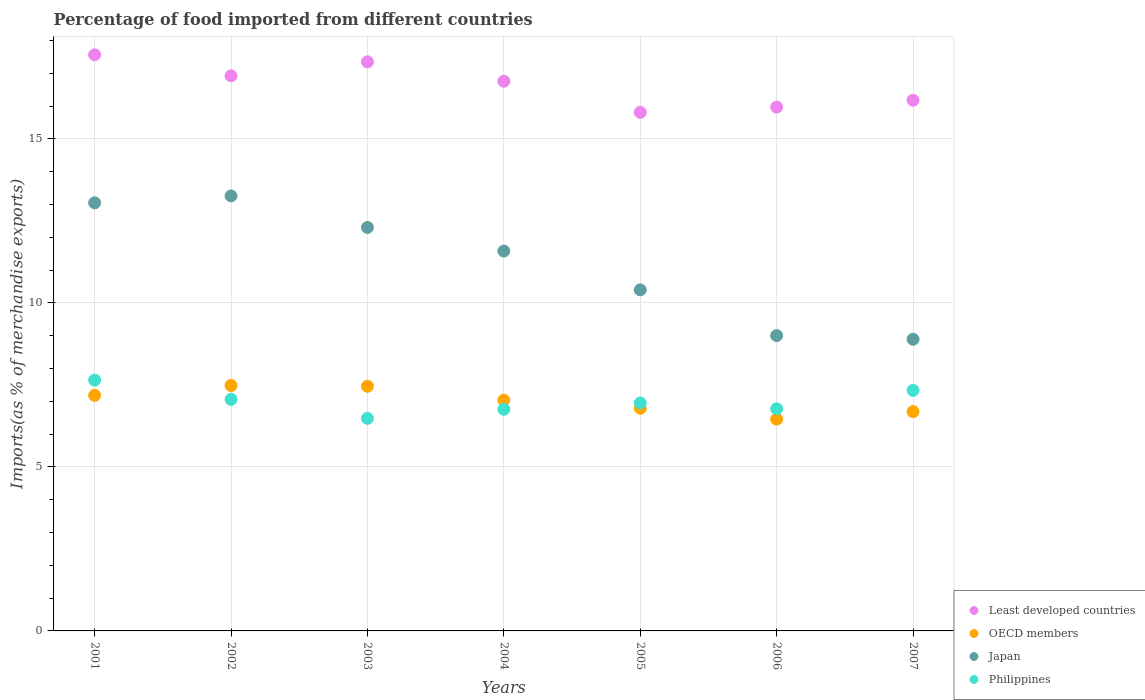What is the percentage of imports to different countries in Japan in 2004?
Your answer should be very brief. 11.58. Across all years, what is the maximum percentage of imports to different countries in Japan?
Provide a succinct answer. 13.26. Across all years, what is the minimum percentage of imports to different countries in Least developed countries?
Your answer should be compact. 15.81. In which year was the percentage of imports to different countries in Philippines minimum?
Offer a terse response. 2003. What is the total percentage of imports to different countries in OECD members in the graph?
Your answer should be compact. 49.08. What is the difference between the percentage of imports to different countries in Japan in 2006 and that in 2007?
Provide a short and direct response. 0.11. What is the difference between the percentage of imports to different countries in Least developed countries in 2006 and the percentage of imports to different countries in OECD members in 2005?
Offer a very short reply. 9.18. What is the average percentage of imports to different countries in Japan per year?
Make the answer very short. 11.21. In the year 2003, what is the difference between the percentage of imports to different countries in Philippines and percentage of imports to different countries in Least developed countries?
Ensure brevity in your answer.  -10.87. In how many years, is the percentage of imports to different countries in Philippines greater than 14 %?
Keep it short and to the point. 0. What is the ratio of the percentage of imports to different countries in Philippines in 2003 to that in 2007?
Make the answer very short. 0.88. Is the percentage of imports to different countries in OECD members in 2006 less than that in 2007?
Ensure brevity in your answer.  Yes. Is the difference between the percentage of imports to different countries in Philippines in 2004 and 2007 greater than the difference between the percentage of imports to different countries in Least developed countries in 2004 and 2007?
Make the answer very short. No. What is the difference between the highest and the second highest percentage of imports to different countries in OECD members?
Your response must be concise. 0.02. What is the difference between the highest and the lowest percentage of imports to different countries in OECD members?
Provide a short and direct response. 1.02. In how many years, is the percentage of imports to different countries in Philippines greater than the average percentage of imports to different countries in Philippines taken over all years?
Make the answer very short. 3. Is it the case that in every year, the sum of the percentage of imports to different countries in Philippines and percentage of imports to different countries in Least developed countries  is greater than the percentage of imports to different countries in OECD members?
Keep it short and to the point. Yes. Does the percentage of imports to different countries in Least developed countries monotonically increase over the years?
Your response must be concise. No. Is the percentage of imports to different countries in Least developed countries strictly greater than the percentage of imports to different countries in Japan over the years?
Ensure brevity in your answer.  Yes. Is the percentage of imports to different countries in Least developed countries strictly less than the percentage of imports to different countries in OECD members over the years?
Offer a terse response. No. How many dotlines are there?
Your answer should be very brief. 4. Where does the legend appear in the graph?
Your answer should be compact. Bottom right. How many legend labels are there?
Your answer should be very brief. 4. What is the title of the graph?
Give a very brief answer. Percentage of food imported from different countries. Does "Mongolia" appear as one of the legend labels in the graph?
Provide a succinct answer. No. What is the label or title of the X-axis?
Offer a terse response. Years. What is the label or title of the Y-axis?
Give a very brief answer. Imports(as % of merchandise exports). What is the Imports(as % of merchandise exports) of Least developed countries in 2001?
Ensure brevity in your answer.  17.56. What is the Imports(as % of merchandise exports) in OECD members in 2001?
Keep it short and to the point. 7.18. What is the Imports(as % of merchandise exports) of Japan in 2001?
Your answer should be compact. 13.05. What is the Imports(as % of merchandise exports) of Philippines in 2001?
Your response must be concise. 7.65. What is the Imports(as % of merchandise exports) in Least developed countries in 2002?
Make the answer very short. 16.92. What is the Imports(as % of merchandise exports) in OECD members in 2002?
Ensure brevity in your answer.  7.48. What is the Imports(as % of merchandise exports) in Japan in 2002?
Your answer should be compact. 13.26. What is the Imports(as % of merchandise exports) in Philippines in 2002?
Provide a succinct answer. 7.06. What is the Imports(as % of merchandise exports) of Least developed countries in 2003?
Ensure brevity in your answer.  17.35. What is the Imports(as % of merchandise exports) in OECD members in 2003?
Offer a terse response. 7.46. What is the Imports(as % of merchandise exports) of Japan in 2003?
Give a very brief answer. 12.3. What is the Imports(as % of merchandise exports) in Philippines in 2003?
Your answer should be compact. 6.48. What is the Imports(as % of merchandise exports) in Least developed countries in 2004?
Ensure brevity in your answer.  16.76. What is the Imports(as % of merchandise exports) of OECD members in 2004?
Offer a very short reply. 7.03. What is the Imports(as % of merchandise exports) of Japan in 2004?
Provide a short and direct response. 11.58. What is the Imports(as % of merchandise exports) of Philippines in 2004?
Ensure brevity in your answer.  6.76. What is the Imports(as % of merchandise exports) of Least developed countries in 2005?
Give a very brief answer. 15.81. What is the Imports(as % of merchandise exports) of OECD members in 2005?
Ensure brevity in your answer.  6.79. What is the Imports(as % of merchandise exports) in Japan in 2005?
Keep it short and to the point. 10.4. What is the Imports(as % of merchandise exports) of Philippines in 2005?
Your answer should be compact. 6.95. What is the Imports(as % of merchandise exports) in Least developed countries in 2006?
Provide a succinct answer. 15.97. What is the Imports(as % of merchandise exports) in OECD members in 2006?
Provide a succinct answer. 6.46. What is the Imports(as % of merchandise exports) of Japan in 2006?
Provide a succinct answer. 9. What is the Imports(as % of merchandise exports) in Philippines in 2006?
Your answer should be very brief. 6.77. What is the Imports(as % of merchandise exports) in Least developed countries in 2007?
Offer a terse response. 16.18. What is the Imports(as % of merchandise exports) in OECD members in 2007?
Keep it short and to the point. 6.69. What is the Imports(as % of merchandise exports) of Japan in 2007?
Ensure brevity in your answer.  8.89. What is the Imports(as % of merchandise exports) of Philippines in 2007?
Make the answer very short. 7.33. Across all years, what is the maximum Imports(as % of merchandise exports) in Least developed countries?
Your answer should be compact. 17.56. Across all years, what is the maximum Imports(as % of merchandise exports) in OECD members?
Offer a very short reply. 7.48. Across all years, what is the maximum Imports(as % of merchandise exports) of Japan?
Ensure brevity in your answer.  13.26. Across all years, what is the maximum Imports(as % of merchandise exports) in Philippines?
Make the answer very short. 7.65. Across all years, what is the minimum Imports(as % of merchandise exports) of Least developed countries?
Your response must be concise. 15.81. Across all years, what is the minimum Imports(as % of merchandise exports) of OECD members?
Offer a terse response. 6.46. Across all years, what is the minimum Imports(as % of merchandise exports) in Japan?
Keep it short and to the point. 8.89. Across all years, what is the minimum Imports(as % of merchandise exports) in Philippines?
Provide a short and direct response. 6.48. What is the total Imports(as % of merchandise exports) in Least developed countries in the graph?
Make the answer very short. 116.54. What is the total Imports(as % of merchandise exports) of OECD members in the graph?
Make the answer very short. 49.08. What is the total Imports(as % of merchandise exports) of Japan in the graph?
Your answer should be compact. 78.48. What is the total Imports(as % of merchandise exports) of Philippines in the graph?
Offer a very short reply. 48.99. What is the difference between the Imports(as % of merchandise exports) of Least developed countries in 2001 and that in 2002?
Give a very brief answer. 0.64. What is the difference between the Imports(as % of merchandise exports) in OECD members in 2001 and that in 2002?
Offer a terse response. -0.3. What is the difference between the Imports(as % of merchandise exports) in Japan in 2001 and that in 2002?
Offer a very short reply. -0.21. What is the difference between the Imports(as % of merchandise exports) in Philippines in 2001 and that in 2002?
Give a very brief answer. 0.59. What is the difference between the Imports(as % of merchandise exports) of Least developed countries in 2001 and that in 2003?
Keep it short and to the point. 0.21. What is the difference between the Imports(as % of merchandise exports) in OECD members in 2001 and that in 2003?
Offer a very short reply. -0.28. What is the difference between the Imports(as % of merchandise exports) in Japan in 2001 and that in 2003?
Offer a terse response. 0.75. What is the difference between the Imports(as % of merchandise exports) of Least developed countries in 2001 and that in 2004?
Ensure brevity in your answer.  0.81. What is the difference between the Imports(as % of merchandise exports) of OECD members in 2001 and that in 2004?
Make the answer very short. 0.15. What is the difference between the Imports(as % of merchandise exports) in Japan in 2001 and that in 2004?
Your answer should be very brief. 1.47. What is the difference between the Imports(as % of merchandise exports) of Philippines in 2001 and that in 2004?
Provide a succinct answer. 0.89. What is the difference between the Imports(as % of merchandise exports) of Least developed countries in 2001 and that in 2005?
Provide a succinct answer. 1.76. What is the difference between the Imports(as % of merchandise exports) of OECD members in 2001 and that in 2005?
Offer a very short reply. 0.39. What is the difference between the Imports(as % of merchandise exports) of Japan in 2001 and that in 2005?
Provide a short and direct response. 2.65. What is the difference between the Imports(as % of merchandise exports) of Philippines in 2001 and that in 2005?
Your answer should be compact. 0.7. What is the difference between the Imports(as % of merchandise exports) of Least developed countries in 2001 and that in 2006?
Your answer should be compact. 1.59. What is the difference between the Imports(as % of merchandise exports) of OECD members in 2001 and that in 2006?
Provide a succinct answer. 0.72. What is the difference between the Imports(as % of merchandise exports) of Japan in 2001 and that in 2006?
Offer a very short reply. 4.05. What is the difference between the Imports(as % of merchandise exports) of Philippines in 2001 and that in 2006?
Offer a terse response. 0.88. What is the difference between the Imports(as % of merchandise exports) in Least developed countries in 2001 and that in 2007?
Provide a short and direct response. 1.38. What is the difference between the Imports(as % of merchandise exports) in OECD members in 2001 and that in 2007?
Your answer should be compact. 0.5. What is the difference between the Imports(as % of merchandise exports) of Japan in 2001 and that in 2007?
Your answer should be very brief. 4.16. What is the difference between the Imports(as % of merchandise exports) of Philippines in 2001 and that in 2007?
Your answer should be very brief. 0.31. What is the difference between the Imports(as % of merchandise exports) of Least developed countries in 2002 and that in 2003?
Your answer should be very brief. -0.43. What is the difference between the Imports(as % of merchandise exports) of OECD members in 2002 and that in 2003?
Ensure brevity in your answer.  0.02. What is the difference between the Imports(as % of merchandise exports) in Japan in 2002 and that in 2003?
Keep it short and to the point. 0.96. What is the difference between the Imports(as % of merchandise exports) of Philippines in 2002 and that in 2003?
Offer a very short reply. 0.58. What is the difference between the Imports(as % of merchandise exports) of Least developed countries in 2002 and that in 2004?
Offer a very short reply. 0.17. What is the difference between the Imports(as % of merchandise exports) in OECD members in 2002 and that in 2004?
Offer a terse response. 0.45. What is the difference between the Imports(as % of merchandise exports) of Japan in 2002 and that in 2004?
Ensure brevity in your answer.  1.68. What is the difference between the Imports(as % of merchandise exports) in Philippines in 2002 and that in 2004?
Your response must be concise. 0.3. What is the difference between the Imports(as % of merchandise exports) of Least developed countries in 2002 and that in 2005?
Your answer should be very brief. 1.11. What is the difference between the Imports(as % of merchandise exports) of OECD members in 2002 and that in 2005?
Provide a succinct answer. 0.69. What is the difference between the Imports(as % of merchandise exports) in Japan in 2002 and that in 2005?
Make the answer very short. 2.86. What is the difference between the Imports(as % of merchandise exports) of Philippines in 2002 and that in 2005?
Keep it short and to the point. 0.11. What is the difference between the Imports(as % of merchandise exports) in Least developed countries in 2002 and that in 2006?
Your answer should be very brief. 0.95. What is the difference between the Imports(as % of merchandise exports) in OECD members in 2002 and that in 2006?
Provide a succinct answer. 1.02. What is the difference between the Imports(as % of merchandise exports) in Japan in 2002 and that in 2006?
Your response must be concise. 4.26. What is the difference between the Imports(as % of merchandise exports) in Philippines in 2002 and that in 2006?
Keep it short and to the point. 0.29. What is the difference between the Imports(as % of merchandise exports) of Least developed countries in 2002 and that in 2007?
Keep it short and to the point. 0.74. What is the difference between the Imports(as % of merchandise exports) in OECD members in 2002 and that in 2007?
Make the answer very short. 0.8. What is the difference between the Imports(as % of merchandise exports) of Japan in 2002 and that in 2007?
Your answer should be very brief. 4.37. What is the difference between the Imports(as % of merchandise exports) in Philippines in 2002 and that in 2007?
Provide a succinct answer. -0.27. What is the difference between the Imports(as % of merchandise exports) of Least developed countries in 2003 and that in 2004?
Your response must be concise. 0.59. What is the difference between the Imports(as % of merchandise exports) in OECD members in 2003 and that in 2004?
Your answer should be very brief. 0.42. What is the difference between the Imports(as % of merchandise exports) of Japan in 2003 and that in 2004?
Provide a succinct answer. 0.72. What is the difference between the Imports(as % of merchandise exports) in Philippines in 2003 and that in 2004?
Make the answer very short. -0.28. What is the difference between the Imports(as % of merchandise exports) of Least developed countries in 2003 and that in 2005?
Your answer should be compact. 1.54. What is the difference between the Imports(as % of merchandise exports) in OECD members in 2003 and that in 2005?
Keep it short and to the point. 0.67. What is the difference between the Imports(as % of merchandise exports) in Japan in 2003 and that in 2005?
Keep it short and to the point. 1.9. What is the difference between the Imports(as % of merchandise exports) of Philippines in 2003 and that in 2005?
Offer a terse response. -0.47. What is the difference between the Imports(as % of merchandise exports) of Least developed countries in 2003 and that in 2006?
Your answer should be compact. 1.38. What is the difference between the Imports(as % of merchandise exports) in Japan in 2003 and that in 2006?
Offer a terse response. 3.3. What is the difference between the Imports(as % of merchandise exports) of Philippines in 2003 and that in 2006?
Offer a terse response. -0.29. What is the difference between the Imports(as % of merchandise exports) in Least developed countries in 2003 and that in 2007?
Provide a short and direct response. 1.17. What is the difference between the Imports(as % of merchandise exports) of OECD members in 2003 and that in 2007?
Your answer should be compact. 0.77. What is the difference between the Imports(as % of merchandise exports) in Japan in 2003 and that in 2007?
Make the answer very short. 3.41. What is the difference between the Imports(as % of merchandise exports) of Philippines in 2003 and that in 2007?
Keep it short and to the point. -0.85. What is the difference between the Imports(as % of merchandise exports) of Least developed countries in 2004 and that in 2005?
Give a very brief answer. 0.95. What is the difference between the Imports(as % of merchandise exports) of OECD members in 2004 and that in 2005?
Your response must be concise. 0.25. What is the difference between the Imports(as % of merchandise exports) of Japan in 2004 and that in 2005?
Offer a very short reply. 1.18. What is the difference between the Imports(as % of merchandise exports) of Philippines in 2004 and that in 2005?
Offer a very short reply. -0.19. What is the difference between the Imports(as % of merchandise exports) in Least developed countries in 2004 and that in 2006?
Your answer should be compact. 0.79. What is the difference between the Imports(as % of merchandise exports) of OECD members in 2004 and that in 2006?
Ensure brevity in your answer.  0.58. What is the difference between the Imports(as % of merchandise exports) of Japan in 2004 and that in 2006?
Your response must be concise. 2.58. What is the difference between the Imports(as % of merchandise exports) in Philippines in 2004 and that in 2006?
Your answer should be compact. -0.01. What is the difference between the Imports(as % of merchandise exports) in Least developed countries in 2004 and that in 2007?
Offer a very short reply. 0.58. What is the difference between the Imports(as % of merchandise exports) of OECD members in 2004 and that in 2007?
Keep it short and to the point. 0.35. What is the difference between the Imports(as % of merchandise exports) in Japan in 2004 and that in 2007?
Your answer should be very brief. 2.69. What is the difference between the Imports(as % of merchandise exports) in Philippines in 2004 and that in 2007?
Offer a very short reply. -0.58. What is the difference between the Imports(as % of merchandise exports) in Least developed countries in 2005 and that in 2006?
Your answer should be compact. -0.16. What is the difference between the Imports(as % of merchandise exports) of OECD members in 2005 and that in 2006?
Your response must be concise. 0.33. What is the difference between the Imports(as % of merchandise exports) of Japan in 2005 and that in 2006?
Ensure brevity in your answer.  1.39. What is the difference between the Imports(as % of merchandise exports) of Philippines in 2005 and that in 2006?
Ensure brevity in your answer.  0.18. What is the difference between the Imports(as % of merchandise exports) of Least developed countries in 2005 and that in 2007?
Keep it short and to the point. -0.37. What is the difference between the Imports(as % of merchandise exports) in OECD members in 2005 and that in 2007?
Your response must be concise. 0.1. What is the difference between the Imports(as % of merchandise exports) of Japan in 2005 and that in 2007?
Ensure brevity in your answer.  1.51. What is the difference between the Imports(as % of merchandise exports) in Philippines in 2005 and that in 2007?
Make the answer very short. -0.39. What is the difference between the Imports(as % of merchandise exports) in Least developed countries in 2006 and that in 2007?
Make the answer very short. -0.21. What is the difference between the Imports(as % of merchandise exports) of OECD members in 2006 and that in 2007?
Make the answer very short. -0.23. What is the difference between the Imports(as % of merchandise exports) in Japan in 2006 and that in 2007?
Offer a terse response. 0.11. What is the difference between the Imports(as % of merchandise exports) of Philippines in 2006 and that in 2007?
Offer a terse response. -0.56. What is the difference between the Imports(as % of merchandise exports) in Least developed countries in 2001 and the Imports(as % of merchandise exports) in OECD members in 2002?
Offer a very short reply. 10.08. What is the difference between the Imports(as % of merchandise exports) of Least developed countries in 2001 and the Imports(as % of merchandise exports) of Japan in 2002?
Ensure brevity in your answer.  4.3. What is the difference between the Imports(as % of merchandise exports) of Least developed countries in 2001 and the Imports(as % of merchandise exports) of Philippines in 2002?
Provide a succinct answer. 10.5. What is the difference between the Imports(as % of merchandise exports) in OECD members in 2001 and the Imports(as % of merchandise exports) in Japan in 2002?
Your answer should be compact. -6.08. What is the difference between the Imports(as % of merchandise exports) in OECD members in 2001 and the Imports(as % of merchandise exports) in Philippines in 2002?
Give a very brief answer. 0.12. What is the difference between the Imports(as % of merchandise exports) of Japan in 2001 and the Imports(as % of merchandise exports) of Philippines in 2002?
Offer a terse response. 5.99. What is the difference between the Imports(as % of merchandise exports) of Least developed countries in 2001 and the Imports(as % of merchandise exports) of OECD members in 2003?
Your response must be concise. 10.11. What is the difference between the Imports(as % of merchandise exports) of Least developed countries in 2001 and the Imports(as % of merchandise exports) of Japan in 2003?
Your response must be concise. 5.26. What is the difference between the Imports(as % of merchandise exports) in Least developed countries in 2001 and the Imports(as % of merchandise exports) in Philippines in 2003?
Ensure brevity in your answer.  11.08. What is the difference between the Imports(as % of merchandise exports) of OECD members in 2001 and the Imports(as % of merchandise exports) of Japan in 2003?
Your answer should be compact. -5.12. What is the difference between the Imports(as % of merchandise exports) of OECD members in 2001 and the Imports(as % of merchandise exports) of Philippines in 2003?
Ensure brevity in your answer.  0.7. What is the difference between the Imports(as % of merchandise exports) of Japan in 2001 and the Imports(as % of merchandise exports) of Philippines in 2003?
Keep it short and to the point. 6.57. What is the difference between the Imports(as % of merchandise exports) in Least developed countries in 2001 and the Imports(as % of merchandise exports) in OECD members in 2004?
Your answer should be very brief. 10.53. What is the difference between the Imports(as % of merchandise exports) in Least developed countries in 2001 and the Imports(as % of merchandise exports) in Japan in 2004?
Your response must be concise. 5.98. What is the difference between the Imports(as % of merchandise exports) in Least developed countries in 2001 and the Imports(as % of merchandise exports) in Philippines in 2004?
Provide a succinct answer. 10.81. What is the difference between the Imports(as % of merchandise exports) in OECD members in 2001 and the Imports(as % of merchandise exports) in Japan in 2004?
Ensure brevity in your answer.  -4.4. What is the difference between the Imports(as % of merchandise exports) in OECD members in 2001 and the Imports(as % of merchandise exports) in Philippines in 2004?
Your response must be concise. 0.43. What is the difference between the Imports(as % of merchandise exports) of Japan in 2001 and the Imports(as % of merchandise exports) of Philippines in 2004?
Give a very brief answer. 6.29. What is the difference between the Imports(as % of merchandise exports) of Least developed countries in 2001 and the Imports(as % of merchandise exports) of OECD members in 2005?
Your response must be concise. 10.78. What is the difference between the Imports(as % of merchandise exports) in Least developed countries in 2001 and the Imports(as % of merchandise exports) in Japan in 2005?
Ensure brevity in your answer.  7.17. What is the difference between the Imports(as % of merchandise exports) of Least developed countries in 2001 and the Imports(as % of merchandise exports) of Philippines in 2005?
Offer a terse response. 10.61. What is the difference between the Imports(as % of merchandise exports) of OECD members in 2001 and the Imports(as % of merchandise exports) of Japan in 2005?
Provide a succinct answer. -3.22. What is the difference between the Imports(as % of merchandise exports) in OECD members in 2001 and the Imports(as % of merchandise exports) in Philippines in 2005?
Your response must be concise. 0.23. What is the difference between the Imports(as % of merchandise exports) of Japan in 2001 and the Imports(as % of merchandise exports) of Philippines in 2005?
Your answer should be compact. 6.1. What is the difference between the Imports(as % of merchandise exports) of Least developed countries in 2001 and the Imports(as % of merchandise exports) of OECD members in 2006?
Offer a very short reply. 11.11. What is the difference between the Imports(as % of merchandise exports) of Least developed countries in 2001 and the Imports(as % of merchandise exports) of Japan in 2006?
Keep it short and to the point. 8.56. What is the difference between the Imports(as % of merchandise exports) in Least developed countries in 2001 and the Imports(as % of merchandise exports) in Philippines in 2006?
Make the answer very short. 10.79. What is the difference between the Imports(as % of merchandise exports) in OECD members in 2001 and the Imports(as % of merchandise exports) in Japan in 2006?
Make the answer very short. -1.82. What is the difference between the Imports(as % of merchandise exports) of OECD members in 2001 and the Imports(as % of merchandise exports) of Philippines in 2006?
Your answer should be compact. 0.41. What is the difference between the Imports(as % of merchandise exports) of Japan in 2001 and the Imports(as % of merchandise exports) of Philippines in 2006?
Your answer should be compact. 6.28. What is the difference between the Imports(as % of merchandise exports) in Least developed countries in 2001 and the Imports(as % of merchandise exports) in OECD members in 2007?
Give a very brief answer. 10.88. What is the difference between the Imports(as % of merchandise exports) in Least developed countries in 2001 and the Imports(as % of merchandise exports) in Japan in 2007?
Make the answer very short. 8.67. What is the difference between the Imports(as % of merchandise exports) in Least developed countries in 2001 and the Imports(as % of merchandise exports) in Philippines in 2007?
Make the answer very short. 10.23. What is the difference between the Imports(as % of merchandise exports) in OECD members in 2001 and the Imports(as % of merchandise exports) in Japan in 2007?
Give a very brief answer. -1.71. What is the difference between the Imports(as % of merchandise exports) in OECD members in 2001 and the Imports(as % of merchandise exports) in Philippines in 2007?
Provide a succinct answer. -0.15. What is the difference between the Imports(as % of merchandise exports) of Japan in 2001 and the Imports(as % of merchandise exports) of Philippines in 2007?
Provide a succinct answer. 5.72. What is the difference between the Imports(as % of merchandise exports) of Least developed countries in 2002 and the Imports(as % of merchandise exports) of OECD members in 2003?
Keep it short and to the point. 9.46. What is the difference between the Imports(as % of merchandise exports) of Least developed countries in 2002 and the Imports(as % of merchandise exports) of Japan in 2003?
Make the answer very short. 4.62. What is the difference between the Imports(as % of merchandise exports) in Least developed countries in 2002 and the Imports(as % of merchandise exports) in Philippines in 2003?
Make the answer very short. 10.44. What is the difference between the Imports(as % of merchandise exports) of OECD members in 2002 and the Imports(as % of merchandise exports) of Japan in 2003?
Ensure brevity in your answer.  -4.82. What is the difference between the Imports(as % of merchandise exports) of OECD members in 2002 and the Imports(as % of merchandise exports) of Philippines in 2003?
Offer a terse response. 1. What is the difference between the Imports(as % of merchandise exports) of Japan in 2002 and the Imports(as % of merchandise exports) of Philippines in 2003?
Give a very brief answer. 6.78. What is the difference between the Imports(as % of merchandise exports) of Least developed countries in 2002 and the Imports(as % of merchandise exports) of OECD members in 2004?
Provide a short and direct response. 9.89. What is the difference between the Imports(as % of merchandise exports) in Least developed countries in 2002 and the Imports(as % of merchandise exports) in Japan in 2004?
Offer a very short reply. 5.34. What is the difference between the Imports(as % of merchandise exports) in Least developed countries in 2002 and the Imports(as % of merchandise exports) in Philippines in 2004?
Your response must be concise. 10.17. What is the difference between the Imports(as % of merchandise exports) in OECD members in 2002 and the Imports(as % of merchandise exports) in Japan in 2004?
Keep it short and to the point. -4.1. What is the difference between the Imports(as % of merchandise exports) of OECD members in 2002 and the Imports(as % of merchandise exports) of Philippines in 2004?
Your answer should be compact. 0.72. What is the difference between the Imports(as % of merchandise exports) of Japan in 2002 and the Imports(as % of merchandise exports) of Philippines in 2004?
Your answer should be compact. 6.5. What is the difference between the Imports(as % of merchandise exports) of Least developed countries in 2002 and the Imports(as % of merchandise exports) of OECD members in 2005?
Make the answer very short. 10.13. What is the difference between the Imports(as % of merchandise exports) in Least developed countries in 2002 and the Imports(as % of merchandise exports) in Japan in 2005?
Keep it short and to the point. 6.52. What is the difference between the Imports(as % of merchandise exports) in Least developed countries in 2002 and the Imports(as % of merchandise exports) in Philippines in 2005?
Make the answer very short. 9.97. What is the difference between the Imports(as % of merchandise exports) of OECD members in 2002 and the Imports(as % of merchandise exports) of Japan in 2005?
Your answer should be very brief. -2.92. What is the difference between the Imports(as % of merchandise exports) in OECD members in 2002 and the Imports(as % of merchandise exports) in Philippines in 2005?
Provide a succinct answer. 0.53. What is the difference between the Imports(as % of merchandise exports) of Japan in 2002 and the Imports(as % of merchandise exports) of Philippines in 2005?
Keep it short and to the point. 6.31. What is the difference between the Imports(as % of merchandise exports) of Least developed countries in 2002 and the Imports(as % of merchandise exports) of OECD members in 2006?
Ensure brevity in your answer.  10.47. What is the difference between the Imports(as % of merchandise exports) of Least developed countries in 2002 and the Imports(as % of merchandise exports) of Japan in 2006?
Your response must be concise. 7.92. What is the difference between the Imports(as % of merchandise exports) of Least developed countries in 2002 and the Imports(as % of merchandise exports) of Philippines in 2006?
Provide a short and direct response. 10.15. What is the difference between the Imports(as % of merchandise exports) in OECD members in 2002 and the Imports(as % of merchandise exports) in Japan in 2006?
Your answer should be very brief. -1.52. What is the difference between the Imports(as % of merchandise exports) in OECD members in 2002 and the Imports(as % of merchandise exports) in Philippines in 2006?
Your answer should be very brief. 0.71. What is the difference between the Imports(as % of merchandise exports) in Japan in 2002 and the Imports(as % of merchandise exports) in Philippines in 2006?
Your answer should be compact. 6.49. What is the difference between the Imports(as % of merchandise exports) of Least developed countries in 2002 and the Imports(as % of merchandise exports) of OECD members in 2007?
Offer a very short reply. 10.24. What is the difference between the Imports(as % of merchandise exports) of Least developed countries in 2002 and the Imports(as % of merchandise exports) of Japan in 2007?
Your answer should be very brief. 8.03. What is the difference between the Imports(as % of merchandise exports) in Least developed countries in 2002 and the Imports(as % of merchandise exports) in Philippines in 2007?
Your response must be concise. 9.59. What is the difference between the Imports(as % of merchandise exports) of OECD members in 2002 and the Imports(as % of merchandise exports) of Japan in 2007?
Your answer should be very brief. -1.41. What is the difference between the Imports(as % of merchandise exports) of OECD members in 2002 and the Imports(as % of merchandise exports) of Philippines in 2007?
Keep it short and to the point. 0.15. What is the difference between the Imports(as % of merchandise exports) in Japan in 2002 and the Imports(as % of merchandise exports) in Philippines in 2007?
Ensure brevity in your answer.  5.93. What is the difference between the Imports(as % of merchandise exports) in Least developed countries in 2003 and the Imports(as % of merchandise exports) in OECD members in 2004?
Provide a short and direct response. 10.31. What is the difference between the Imports(as % of merchandise exports) in Least developed countries in 2003 and the Imports(as % of merchandise exports) in Japan in 2004?
Offer a very short reply. 5.77. What is the difference between the Imports(as % of merchandise exports) in Least developed countries in 2003 and the Imports(as % of merchandise exports) in Philippines in 2004?
Provide a short and direct response. 10.59. What is the difference between the Imports(as % of merchandise exports) in OECD members in 2003 and the Imports(as % of merchandise exports) in Japan in 2004?
Your answer should be very brief. -4.12. What is the difference between the Imports(as % of merchandise exports) of OECD members in 2003 and the Imports(as % of merchandise exports) of Philippines in 2004?
Give a very brief answer. 0.7. What is the difference between the Imports(as % of merchandise exports) of Japan in 2003 and the Imports(as % of merchandise exports) of Philippines in 2004?
Give a very brief answer. 5.54. What is the difference between the Imports(as % of merchandise exports) of Least developed countries in 2003 and the Imports(as % of merchandise exports) of OECD members in 2005?
Your response must be concise. 10.56. What is the difference between the Imports(as % of merchandise exports) of Least developed countries in 2003 and the Imports(as % of merchandise exports) of Japan in 2005?
Give a very brief answer. 6.95. What is the difference between the Imports(as % of merchandise exports) of Least developed countries in 2003 and the Imports(as % of merchandise exports) of Philippines in 2005?
Keep it short and to the point. 10.4. What is the difference between the Imports(as % of merchandise exports) of OECD members in 2003 and the Imports(as % of merchandise exports) of Japan in 2005?
Give a very brief answer. -2.94. What is the difference between the Imports(as % of merchandise exports) of OECD members in 2003 and the Imports(as % of merchandise exports) of Philippines in 2005?
Provide a succinct answer. 0.51. What is the difference between the Imports(as % of merchandise exports) in Japan in 2003 and the Imports(as % of merchandise exports) in Philippines in 2005?
Ensure brevity in your answer.  5.35. What is the difference between the Imports(as % of merchandise exports) of Least developed countries in 2003 and the Imports(as % of merchandise exports) of OECD members in 2006?
Provide a succinct answer. 10.89. What is the difference between the Imports(as % of merchandise exports) of Least developed countries in 2003 and the Imports(as % of merchandise exports) of Japan in 2006?
Give a very brief answer. 8.35. What is the difference between the Imports(as % of merchandise exports) in Least developed countries in 2003 and the Imports(as % of merchandise exports) in Philippines in 2006?
Your answer should be compact. 10.58. What is the difference between the Imports(as % of merchandise exports) in OECD members in 2003 and the Imports(as % of merchandise exports) in Japan in 2006?
Make the answer very short. -1.55. What is the difference between the Imports(as % of merchandise exports) in OECD members in 2003 and the Imports(as % of merchandise exports) in Philippines in 2006?
Provide a succinct answer. 0.69. What is the difference between the Imports(as % of merchandise exports) in Japan in 2003 and the Imports(as % of merchandise exports) in Philippines in 2006?
Give a very brief answer. 5.53. What is the difference between the Imports(as % of merchandise exports) of Least developed countries in 2003 and the Imports(as % of merchandise exports) of OECD members in 2007?
Offer a terse response. 10.66. What is the difference between the Imports(as % of merchandise exports) in Least developed countries in 2003 and the Imports(as % of merchandise exports) in Japan in 2007?
Your answer should be compact. 8.46. What is the difference between the Imports(as % of merchandise exports) of Least developed countries in 2003 and the Imports(as % of merchandise exports) of Philippines in 2007?
Offer a terse response. 10.02. What is the difference between the Imports(as % of merchandise exports) of OECD members in 2003 and the Imports(as % of merchandise exports) of Japan in 2007?
Keep it short and to the point. -1.43. What is the difference between the Imports(as % of merchandise exports) in OECD members in 2003 and the Imports(as % of merchandise exports) in Philippines in 2007?
Your answer should be very brief. 0.12. What is the difference between the Imports(as % of merchandise exports) of Japan in 2003 and the Imports(as % of merchandise exports) of Philippines in 2007?
Keep it short and to the point. 4.97. What is the difference between the Imports(as % of merchandise exports) in Least developed countries in 2004 and the Imports(as % of merchandise exports) in OECD members in 2005?
Provide a succinct answer. 9.97. What is the difference between the Imports(as % of merchandise exports) in Least developed countries in 2004 and the Imports(as % of merchandise exports) in Japan in 2005?
Make the answer very short. 6.36. What is the difference between the Imports(as % of merchandise exports) of Least developed countries in 2004 and the Imports(as % of merchandise exports) of Philippines in 2005?
Offer a very short reply. 9.81. What is the difference between the Imports(as % of merchandise exports) of OECD members in 2004 and the Imports(as % of merchandise exports) of Japan in 2005?
Your answer should be compact. -3.36. What is the difference between the Imports(as % of merchandise exports) in OECD members in 2004 and the Imports(as % of merchandise exports) in Philippines in 2005?
Give a very brief answer. 0.09. What is the difference between the Imports(as % of merchandise exports) of Japan in 2004 and the Imports(as % of merchandise exports) of Philippines in 2005?
Provide a succinct answer. 4.63. What is the difference between the Imports(as % of merchandise exports) in Least developed countries in 2004 and the Imports(as % of merchandise exports) in OECD members in 2006?
Your answer should be compact. 10.3. What is the difference between the Imports(as % of merchandise exports) in Least developed countries in 2004 and the Imports(as % of merchandise exports) in Japan in 2006?
Give a very brief answer. 7.75. What is the difference between the Imports(as % of merchandise exports) of Least developed countries in 2004 and the Imports(as % of merchandise exports) of Philippines in 2006?
Provide a succinct answer. 9.99. What is the difference between the Imports(as % of merchandise exports) of OECD members in 2004 and the Imports(as % of merchandise exports) of Japan in 2006?
Make the answer very short. -1.97. What is the difference between the Imports(as % of merchandise exports) in OECD members in 2004 and the Imports(as % of merchandise exports) in Philippines in 2006?
Your response must be concise. 0.26. What is the difference between the Imports(as % of merchandise exports) of Japan in 2004 and the Imports(as % of merchandise exports) of Philippines in 2006?
Keep it short and to the point. 4.81. What is the difference between the Imports(as % of merchandise exports) of Least developed countries in 2004 and the Imports(as % of merchandise exports) of OECD members in 2007?
Keep it short and to the point. 10.07. What is the difference between the Imports(as % of merchandise exports) in Least developed countries in 2004 and the Imports(as % of merchandise exports) in Japan in 2007?
Give a very brief answer. 7.86. What is the difference between the Imports(as % of merchandise exports) in Least developed countries in 2004 and the Imports(as % of merchandise exports) in Philippines in 2007?
Offer a very short reply. 9.42. What is the difference between the Imports(as % of merchandise exports) in OECD members in 2004 and the Imports(as % of merchandise exports) in Japan in 2007?
Ensure brevity in your answer.  -1.86. What is the difference between the Imports(as % of merchandise exports) in OECD members in 2004 and the Imports(as % of merchandise exports) in Philippines in 2007?
Provide a succinct answer. -0.3. What is the difference between the Imports(as % of merchandise exports) of Japan in 2004 and the Imports(as % of merchandise exports) of Philippines in 2007?
Your answer should be compact. 4.25. What is the difference between the Imports(as % of merchandise exports) of Least developed countries in 2005 and the Imports(as % of merchandise exports) of OECD members in 2006?
Offer a terse response. 9.35. What is the difference between the Imports(as % of merchandise exports) in Least developed countries in 2005 and the Imports(as % of merchandise exports) in Japan in 2006?
Your response must be concise. 6.8. What is the difference between the Imports(as % of merchandise exports) in Least developed countries in 2005 and the Imports(as % of merchandise exports) in Philippines in 2006?
Offer a terse response. 9.04. What is the difference between the Imports(as % of merchandise exports) in OECD members in 2005 and the Imports(as % of merchandise exports) in Japan in 2006?
Offer a very short reply. -2.22. What is the difference between the Imports(as % of merchandise exports) in OECD members in 2005 and the Imports(as % of merchandise exports) in Philippines in 2006?
Offer a terse response. 0.02. What is the difference between the Imports(as % of merchandise exports) in Japan in 2005 and the Imports(as % of merchandise exports) in Philippines in 2006?
Ensure brevity in your answer.  3.63. What is the difference between the Imports(as % of merchandise exports) in Least developed countries in 2005 and the Imports(as % of merchandise exports) in OECD members in 2007?
Give a very brief answer. 9.12. What is the difference between the Imports(as % of merchandise exports) in Least developed countries in 2005 and the Imports(as % of merchandise exports) in Japan in 2007?
Offer a terse response. 6.92. What is the difference between the Imports(as % of merchandise exports) of Least developed countries in 2005 and the Imports(as % of merchandise exports) of Philippines in 2007?
Offer a very short reply. 8.47. What is the difference between the Imports(as % of merchandise exports) of OECD members in 2005 and the Imports(as % of merchandise exports) of Japan in 2007?
Keep it short and to the point. -2.1. What is the difference between the Imports(as % of merchandise exports) of OECD members in 2005 and the Imports(as % of merchandise exports) of Philippines in 2007?
Your response must be concise. -0.55. What is the difference between the Imports(as % of merchandise exports) in Japan in 2005 and the Imports(as % of merchandise exports) in Philippines in 2007?
Make the answer very short. 3.06. What is the difference between the Imports(as % of merchandise exports) in Least developed countries in 2006 and the Imports(as % of merchandise exports) in OECD members in 2007?
Your response must be concise. 9.28. What is the difference between the Imports(as % of merchandise exports) of Least developed countries in 2006 and the Imports(as % of merchandise exports) of Japan in 2007?
Your answer should be very brief. 7.08. What is the difference between the Imports(as % of merchandise exports) of Least developed countries in 2006 and the Imports(as % of merchandise exports) of Philippines in 2007?
Your response must be concise. 8.64. What is the difference between the Imports(as % of merchandise exports) of OECD members in 2006 and the Imports(as % of merchandise exports) of Japan in 2007?
Make the answer very short. -2.43. What is the difference between the Imports(as % of merchandise exports) of OECD members in 2006 and the Imports(as % of merchandise exports) of Philippines in 2007?
Provide a short and direct response. -0.88. What is the difference between the Imports(as % of merchandise exports) in Japan in 2006 and the Imports(as % of merchandise exports) in Philippines in 2007?
Your answer should be compact. 1.67. What is the average Imports(as % of merchandise exports) of Least developed countries per year?
Provide a short and direct response. 16.65. What is the average Imports(as % of merchandise exports) of OECD members per year?
Provide a succinct answer. 7.01. What is the average Imports(as % of merchandise exports) of Japan per year?
Your response must be concise. 11.21. What is the average Imports(as % of merchandise exports) of Philippines per year?
Ensure brevity in your answer.  7. In the year 2001, what is the difference between the Imports(as % of merchandise exports) of Least developed countries and Imports(as % of merchandise exports) of OECD members?
Make the answer very short. 10.38. In the year 2001, what is the difference between the Imports(as % of merchandise exports) in Least developed countries and Imports(as % of merchandise exports) in Japan?
Ensure brevity in your answer.  4.51. In the year 2001, what is the difference between the Imports(as % of merchandise exports) in Least developed countries and Imports(as % of merchandise exports) in Philippines?
Provide a succinct answer. 9.92. In the year 2001, what is the difference between the Imports(as % of merchandise exports) in OECD members and Imports(as % of merchandise exports) in Japan?
Your answer should be very brief. -5.87. In the year 2001, what is the difference between the Imports(as % of merchandise exports) of OECD members and Imports(as % of merchandise exports) of Philippines?
Give a very brief answer. -0.46. In the year 2001, what is the difference between the Imports(as % of merchandise exports) in Japan and Imports(as % of merchandise exports) in Philippines?
Keep it short and to the point. 5.4. In the year 2002, what is the difference between the Imports(as % of merchandise exports) of Least developed countries and Imports(as % of merchandise exports) of OECD members?
Offer a terse response. 9.44. In the year 2002, what is the difference between the Imports(as % of merchandise exports) in Least developed countries and Imports(as % of merchandise exports) in Japan?
Your response must be concise. 3.66. In the year 2002, what is the difference between the Imports(as % of merchandise exports) in Least developed countries and Imports(as % of merchandise exports) in Philippines?
Provide a succinct answer. 9.86. In the year 2002, what is the difference between the Imports(as % of merchandise exports) in OECD members and Imports(as % of merchandise exports) in Japan?
Provide a short and direct response. -5.78. In the year 2002, what is the difference between the Imports(as % of merchandise exports) of OECD members and Imports(as % of merchandise exports) of Philippines?
Your answer should be very brief. 0.42. In the year 2002, what is the difference between the Imports(as % of merchandise exports) in Japan and Imports(as % of merchandise exports) in Philippines?
Provide a succinct answer. 6.2. In the year 2003, what is the difference between the Imports(as % of merchandise exports) of Least developed countries and Imports(as % of merchandise exports) of OECD members?
Provide a short and direct response. 9.89. In the year 2003, what is the difference between the Imports(as % of merchandise exports) of Least developed countries and Imports(as % of merchandise exports) of Japan?
Give a very brief answer. 5.05. In the year 2003, what is the difference between the Imports(as % of merchandise exports) in Least developed countries and Imports(as % of merchandise exports) in Philippines?
Give a very brief answer. 10.87. In the year 2003, what is the difference between the Imports(as % of merchandise exports) of OECD members and Imports(as % of merchandise exports) of Japan?
Offer a terse response. -4.84. In the year 2003, what is the difference between the Imports(as % of merchandise exports) in OECD members and Imports(as % of merchandise exports) in Philippines?
Provide a succinct answer. 0.98. In the year 2003, what is the difference between the Imports(as % of merchandise exports) of Japan and Imports(as % of merchandise exports) of Philippines?
Make the answer very short. 5.82. In the year 2004, what is the difference between the Imports(as % of merchandise exports) in Least developed countries and Imports(as % of merchandise exports) in OECD members?
Give a very brief answer. 9.72. In the year 2004, what is the difference between the Imports(as % of merchandise exports) of Least developed countries and Imports(as % of merchandise exports) of Japan?
Offer a very short reply. 5.18. In the year 2004, what is the difference between the Imports(as % of merchandise exports) of Least developed countries and Imports(as % of merchandise exports) of Philippines?
Your response must be concise. 10. In the year 2004, what is the difference between the Imports(as % of merchandise exports) in OECD members and Imports(as % of merchandise exports) in Japan?
Ensure brevity in your answer.  -4.55. In the year 2004, what is the difference between the Imports(as % of merchandise exports) in OECD members and Imports(as % of merchandise exports) in Philippines?
Offer a terse response. 0.28. In the year 2004, what is the difference between the Imports(as % of merchandise exports) of Japan and Imports(as % of merchandise exports) of Philippines?
Your answer should be very brief. 4.82. In the year 2005, what is the difference between the Imports(as % of merchandise exports) of Least developed countries and Imports(as % of merchandise exports) of OECD members?
Provide a short and direct response. 9.02. In the year 2005, what is the difference between the Imports(as % of merchandise exports) of Least developed countries and Imports(as % of merchandise exports) of Japan?
Offer a terse response. 5.41. In the year 2005, what is the difference between the Imports(as % of merchandise exports) in Least developed countries and Imports(as % of merchandise exports) in Philippines?
Provide a short and direct response. 8.86. In the year 2005, what is the difference between the Imports(as % of merchandise exports) of OECD members and Imports(as % of merchandise exports) of Japan?
Offer a terse response. -3.61. In the year 2005, what is the difference between the Imports(as % of merchandise exports) of OECD members and Imports(as % of merchandise exports) of Philippines?
Your answer should be very brief. -0.16. In the year 2005, what is the difference between the Imports(as % of merchandise exports) in Japan and Imports(as % of merchandise exports) in Philippines?
Provide a short and direct response. 3.45. In the year 2006, what is the difference between the Imports(as % of merchandise exports) of Least developed countries and Imports(as % of merchandise exports) of OECD members?
Offer a very short reply. 9.51. In the year 2006, what is the difference between the Imports(as % of merchandise exports) in Least developed countries and Imports(as % of merchandise exports) in Japan?
Provide a succinct answer. 6.97. In the year 2006, what is the difference between the Imports(as % of merchandise exports) in Least developed countries and Imports(as % of merchandise exports) in Philippines?
Offer a very short reply. 9.2. In the year 2006, what is the difference between the Imports(as % of merchandise exports) in OECD members and Imports(as % of merchandise exports) in Japan?
Ensure brevity in your answer.  -2.55. In the year 2006, what is the difference between the Imports(as % of merchandise exports) of OECD members and Imports(as % of merchandise exports) of Philippines?
Your answer should be very brief. -0.31. In the year 2006, what is the difference between the Imports(as % of merchandise exports) in Japan and Imports(as % of merchandise exports) in Philippines?
Provide a succinct answer. 2.23. In the year 2007, what is the difference between the Imports(as % of merchandise exports) in Least developed countries and Imports(as % of merchandise exports) in OECD members?
Provide a short and direct response. 9.49. In the year 2007, what is the difference between the Imports(as % of merchandise exports) in Least developed countries and Imports(as % of merchandise exports) in Japan?
Provide a succinct answer. 7.29. In the year 2007, what is the difference between the Imports(as % of merchandise exports) of Least developed countries and Imports(as % of merchandise exports) of Philippines?
Ensure brevity in your answer.  8.84. In the year 2007, what is the difference between the Imports(as % of merchandise exports) of OECD members and Imports(as % of merchandise exports) of Japan?
Offer a terse response. -2.21. In the year 2007, what is the difference between the Imports(as % of merchandise exports) in OECD members and Imports(as % of merchandise exports) in Philippines?
Your answer should be very brief. -0.65. In the year 2007, what is the difference between the Imports(as % of merchandise exports) of Japan and Imports(as % of merchandise exports) of Philippines?
Offer a very short reply. 1.56. What is the ratio of the Imports(as % of merchandise exports) in Least developed countries in 2001 to that in 2002?
Make the answer very short. 1.04. What is the ratio of the Imports(as % of merchandise exports) of OECD members in 2001 to that in 2002?
Your answer should be compact. 0.96. What is the ratio of the Imports(as % of merchandise exports) in Japan in 2001 to that in 2002?
Ensure brevity in your answer.  0.98. What is the ratio of the Imports(as % of merchandise exports) of Philippines in 2001 to that in 2002?
Keep it short and to the point. 1.08. What is the ratio of the Imports(as % of merchandise exports) in Least developed countries in 2001 to that in 2003?
Offer a very short reply. 1.01. What is the ratio of the Imports(as % of merchandise exports) of OECD members in 2001 to that in 2003?
Give a very brief answer. 0.96. What is the ratio of the Imports(as % of merchandise exports) of Japan in 2001 to that in 2003?
Your answer should be very brief. 1.06. What is the ratio of the Imports(as % of merchandise exports) of Philippines in 2001 to that in 2003?
Keep it short and to the point. 1.18. What is the ratio of the Imports(as % of merchandise exports) in Least developed countries in 2001 to that in 2004?
Your answer should be compact. 1.05. What is the ratio of the Imports(as % of merchandise exports) of OECD members in 2001 to that in 2004?
Keep it short and to the point. 1.02. What is the ratio of the Imports(as % of merchandise exports) in Japan in 2001 to that in 2004?
Ensure brevity in your answer.  1.13. What is the ratio of the Imports(as % of merchandise exports) of Philippines in 2001 to that in 2004?
Ensure brevity in your answer.  1.13. What is the ratio of the Imports(as % of merchandise exports) in Least developed countries in 2001 to that in 2005?
Your answer should be very brief. 1.11. What is the ratio of the Imports(as % of merchandise exports) of OECD members in 2001 to that in 2005?
Provide a succinct answer. 1.06. What is the ratio of the Imports(as % of merchandise exports) of Japan in 2001 to that in 2005?
Keep it short and to the point. 1.26. What is the ratio of the Imports(as % of merchandise exports) of Philippines in 2001 to that in 2005?
Your answer should be very brief. 1.1. What is the ratio of the Imports(as % of merchandise exports) of Least developed countries in 2001 to that in 2006?
Your answer should be very brief. 1.1. What is the ratio of the Imports(as % of merchandise exports) of OECD members in 2001 to that in 2006?
Offer a terse response. 1.11. What is the ratio of the Imports(as % of merchandise exports) in Japan in 2001 to that in 2006?
Your answer should be very brief. 1.45. What is the ratio of the Imports(as % of merchandise exports) of Philippines in 2001 to that in 2006?
Your answer should be very brief. 1.13. What is the ratio of the Imports(as % of merchandise exports) of Least developed countries in 2001 to that in 2007?
Your answer should be compact. 1.09. What is the ratio of the Imports(as % of merchandise exports) in OECD members in 2001 to that in 2007?
Provide a short and direct response. 1.07. What is the ratio of the Imports(as % of merchandise exports) of Japan in 2001 to that in 2007?
Your answer should be compact. 1.47. What is the ratio of the Imports(as % of merchandise exports) in Philippines in 2001 to that in 2007?
Provide a succinct answer. 1.04. What is the ratio of the Imports(as % of merchandise exports) in Least developed countries in 2002 to that in 2003?
Give a very brief answer. 0.98. What is the ratio of the Imports(as % of merchandise exports) of Japan in 2002 to that in 2003?
Your response must be concise. 1.08. What is the ratio of the Imports(as % of merchandise exports) of Philippines in 2002 to that in 2003?
Keep it short and to the point. 1.09. What is the ratio of the Imports(as % of merchandise exports) in Least developed countries in 2002 to that in 2004?
Your response must be concise. 1.01. What is the ratio of the Imports(as % of merchandise exports) of OECD members in 2002 to that in 2004?
Keep it short and to the point. 1.06. What is the ratio of the Imports(as % of merchandise exports) of Japan in 2002 to that in 2004?
Offer a very short reply. 1.15. What is the ratio of the Imports(as % of merchandise exports) of Philippines in 2002 to that in 2004?
Provide a short and direct response. 1.04. What is the ratio of the Imports(as % of merchandise exports) in Least developed countries in 2002 to that in 2005?
Provide a succinct answer. 1.07. What is the ratio of the Imports(as % of merchandise exports) of OECD members in 2002 to that in 2005?
Your answer should be compact. 1.1. What is the ratio of the Imports(as % of merchandise exports) of Japan in 2002 to that in 2005?
Offer a very short reply. 1.28. What is the ratio of the Imports(as % of merchandise exports) of Philippines in 2002 to that in 2005?
Your answer should be very brief. 1.02. What is the ratio of the Imports(as % of merchandise exports) of Least developed countries in 2002 to that in 2006?
Offer a very short reply. 1.06. What is the ratio of the Imports(as % of merchandise exports) in OECD members in 2002 to that in 2006?
Make the answer very short. 1.16. What is the ratio of the Imports(as % of merchandise exports) of Japan in 2002 to that in 2006?
Your response must be concise. 1.47. What is the ratio of the Imports(as % of merchandise exports) of Philippines in 2002 to that in 2006?
Your response must be concise. 1.04. What is the ratio of the Imports(as % of merchandise exports) in Least developed countries in 2002 to that in 2007?
Offer a very short reply. 1.05. What is the ratio of the Imports(as % of merchandise exports) in OECD members in 2002 to that in 2007?
Make the answer very short. 1.12. What is the ratio of the Imports(as % of merchandise exports) in Japan in 2002 to that in 2007?
Give a very brief answer. 1.49. What is the ratio of the Imports(as % of merchandise exports) in Philippines in 2002 to that in 2007?
Make the answer very short. 0.96. What is the ratio of the Imports(as % of merchandise exports) in Least developed countries in 2003 to that in 2004?
Your response must be concise. 1.04. What is the ratio of the Imports(as % of merchandise exports) of OECD members in 2003 to that in 2004?
Offer a terse response. 1.06. What is the ratio of the Imports(as % of merchandise exports) of Japan in 2003 to that in 2004?
Ensure brevity in your answer.  1.06. What is the ratio of the Imports(as % of merchandise exports) of Philippines in 2003 to that in 2004?
Your response must be concise. 0.96. What is the ratio of the Imports(as % of merchandise exports) in Least developed countries in 2003 to that in 2005?
Your answer should be compact. 1.1. What is the ratio of the Imports(as % of merchandise exports) of OECD members in 2003 to that in 2005?
Provide a short and direct response. 1.1. What is the ratio of the Imports(as % of merchandise exports) of Japan in 2003 to that in 2005?
Provide a succinct answer. 1.18. What is the ratio of the Imports(as % of merchandise exports) of Philippines in 2003 to that in 2005?
Give a very brief answer. 0.93. What is the ratio of the Imports(as % of merchandise exports) in Least developed countries in 2003 to that in 2006?
Your answer should be very brief. 1.09. What is the ratio of the Imports(as % of merchandise exports) of OECD members in 2003 to that in 2006?
Keep it short and to the point. 1.15. What is the ratio of the Imports(as % of merchandise exports) of Japan in 2003 to that in 2006?
Your answer should be compact. 1.37. What is the ratio of the Imports(as % of merchandise exports) of Philippines in 2003 to that in 2006?
Your answer should be compact. 0.96. What is the ratio of the Imports(as % of merchandise exports) of Least developed countries in 2003 to that in 2007?
Offer a very short reply. 1.07. What is the ratio of the Imports(as % of merchandise exports) of OECD members in 2003 to that in 2007?
Give a very brief answer. 1.12. What is the ratio of the Imports(as % of merchandise exports) of Japan in 2003 to that in 2007?
Ensure brevity in your answer.  1.38. What is the ratio of the Imports(as % of merchandise exports) in Philippines in 2003 to that in 2007?
Keep it short and to the point. 0.88. What is the ratio of the Imports(as % of merchandise exports) of Least developed countries in 2004 to that in 2005?
Make the answer very short. 1.06. What is the ratio of the Imports(as % of merchandise exports) of OECD members in 2004 to that in 2005?
Make the answer very short. 1.04. What is the ratio of the Imports(as % of merchandise exports) of Japan in 2004 to that in 2005?
Offer a terse response. 1.11. What is the ratio of the Imports(as % of merchandise exports) of Philippines in 2004 to that in 2005?
Your answer should be very brief. 0.97. What is the ratio of the Imports(as % of merchandise exports) in Least developed countries in 2004 to that in 2006?
Ensure brevity in your answer.  1.05. What is the ratio of the Imports(as % of merchandise exports) in OECD members in 2004 to that in 2006?
Provide a succinct answer. 1.09. What is the ratio of the Imports(as % of merchandise exports) in Japan in 2004 to that in 2006?
Make the answer very short. 1.29. What is the ratio of the Imports(as % of merchandise exports) of Least developed countries in 2004 to that in 2007?
Provide a short and direct response. 1.04. What is the ratio of the Imports(as % of merchandise exports) of OECD members in 2004 to that in 2007?
Your answer should be compact. 1.05. What is the ratio of the Imports(as % of merchandise exports) in Japan in 2004 to that in 2007?
Keep it short and to the point. 1.3. What is the ratio of the Imports(as % of merchandise exports) in Philippines in 2004 to that in 2007?
Provide a short and direct response. 0.92. What is the ratio of the Imports(as % of merchandise exports) of Least developed countries in 2005 to that in 2006?
Provide a short and direct response. 0.99. What is the ratio of the Imports(as % of merchandise exports) in OECD members in 2005 to that in 2006?
Your answer should be very brief. 1.05. What is the ratio of the Imports(as % of merchandise exports) of Japan in 2005 to that in 2006?
Offer a terse response. 1.15. What is the ratio of the Imports(as % of merchandise exports) in Philippines in 2005 to that in 2006?
Your response must be concise. 1.03. What is the ratio of the Imports(as % of merchandise exports) of Least developed countries in 2005 to that in 2007?
Provide a short and direct response. 0.98. What is the ratio of the Imports(as % of merchandise exports) in OECD members in 2005 to that in 2007?
Your answer should be compact. 1.02. What is the ratio of the Imports(as % of merchandise exports) in Japan in 2005 to that in 2007?
Offer a very short reply. 1.17. What is the ratio of the Imports(as % of merchandise exports) in Philippines in 2005 to that in 2007?
Ensure brevity in your answer.  0.95. What is the ratio of the Imports(as % of merchandise exports) in Least developed countries in 2006 to that in 2007?
Keep it short and to the point. 0.99. What is the ratio of the Imports(as % of merchandise exports) of OECD members in 2006 to that in 2007?
Your answer should be compact. 0.97. What is the ratio of the Imports(as % of merchandise exports) in Japan in 2006 to that in 2007?
Your answer should be compact. 1.01. What is the ratio of the Imports(as % of merchandise exports) of Philippines in 2006 to that in 2007?
Your answer should be very brief. 0.92. What is the difference between the highest and the second highest Imports(as % of merchandise exports) in Least developed countries?
Make the answer very short. 0.21. What is the difference between the highest and the second highest Imports(as % of merchandise exports) in OECD members?
Offer a terse response. 0.02. What is the difference between the highest and the second highest Imports(as % of merchandise exports) of Japan?
Keep it short and to the point. 0.21. What is the difference between the highest and the second highest Imports(as % of merchandise exports) in Philippines?
Provide a short and direct response. 0.31. What is the difference between the highest and the lowest Imports(as % of merchandise exports) in Least developed countries?
Provide a short and direct response. 1.76. What is the difference between the highest and the lowest Imports(as % of merchandise exports) of OECD members?
Offer a terse response. 1.02. What is the difference between the highest and the lowest Imports(as % of merchandise exports) of Japan?
Make the answer very short. 4.37. What is the difference between the highest and the lowest Imports(as % of merchandise exports) of Philippines?
Give a very brief answer. 1.17. 